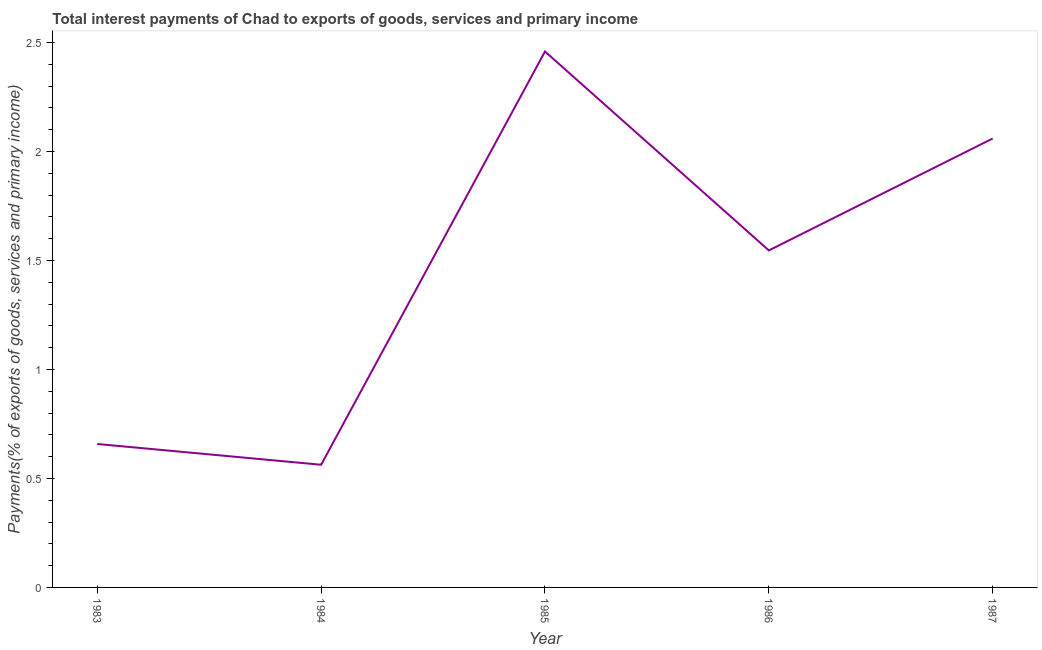What is the total interest payments on external debt in 1987?
Offer a terse response. 2.06. Across all years, what is the maximum total interest payments on external debt?
Provide a succinct answer. 2.46. Across all years, what is the minimum total interest payments on external debt?
Offer a very short reply. 0.56. In which year was the total interest payments on external debt maximum?
Provide a short and direct response. 1985. What is the sum of the total interest payments on external debt?
Ensure brevity in your answer.  7.28. What is the difference between the total interest payments on external debt in 1983 and 1984?
Provide a succinct answer. 0.1. What is the average total interest payments on external debt per year?
Give a very brief answer. 1.46. What is the median total interest payments on external debt?
Make the answer very short. 1.55. In how many years, is the total interest payments on external debt greater than 0.2 %?
Your answer should be compact. 5. What is the ratio of the total interest payments on external debt in 1983 to that in 1987?
Ensure brevity in your answer.  0.32. What is the difference between the highest and the second highest total interest payments on external debt?
Your answer should be very brief. 0.4. Is the sum of the total interest payments on external debt in 1983 and 1987 greater than the maximum total interest payments on external debt across all years?
Your answer should be compact. Yes. What is the difference between the highest and the lowest total interest payments on external debt?
Provide a succinct answer. 1.9. In how many years, is the total interest payments on external debt greater than the average total interest payments on external debt taken over all years?
Your answer should be compact. 3. Does the total interest payments on external debt monotonically increase over the years?
Your response must be concise. No. How many years are there in the graph?
Your answer should be compact. 5. Does the graph contain any zero values?
Ensure brevity in your answer.  No. Does the graph contain grids?
Keep it short and to the point. No. What is the title of the graph?
Make the answer very short. Total interest payments of Chad to exports of goods, services and primary income. What is the label or title of the X-axis?
Give a very brief answer. Year. What is the label or title of the Y-axis?
Ensure brevity in your answer.  Payments(% of exports of goods, services and primary income). What is the Payments(% of exports of goods, services and primary income) of 1983?
Make the answer very short. 0.66. What is the Payments(% of exports of goods, services and primary income) in 1984?
Your answer should be very brief. 0.56. What is the Payments(% of exports of goods, services and primary income) in 1985?
Your response must be concise. 2.46. What is the Payments(% of exports of goods, services and primary income) of 1986?
Provide a short and direct response. 1.55. What is the Payments(% of exports of goods, services and primary income) of 1987?
Your answer should be compact. 2.06. What is the difference between the Payments(% of exports of goods, services and primary income) in 1983 and 1984?
Give a very brief answer. 0.1. What is the difference between the Payments(% of exports of goods, services and primary income) in 1983 and 1985?
Make the answer very short. -1.8. What is the difference between the Payments(% of exports of goods, services and primary income) in 1983 and 1986?
Offer a terse response. -0.89. What is the difference between the Payments(% of exports of goods, services and primary income) in 1983 and 1987?
Make the answer very short. -1.4. What is the difference between the Payments(% of exports of goods, services and primary income) in 1984 and 1985?
Offer a very short reply. -1.9. What is the difference between the Payments(% of exports of goods, services and primary income) in 1984 and 1986?
Keep it short and to the point. -0.98. What is the difference between the Payments(% of exports of goods, services and primary income) in 1984 and 1987?
Offer a very short reply. -1.5. What is the difference between the Payments(% of exports of goods, services and primary income) in 1985 and 1986?
Your answer should be compact. 0.91. What is the difference between the Payments(% of exports of goods, services and primary income) in 1985 and 1987?
Give a very brief answer. 0.4. What is the difference between the Payments(% of exports of goods, services and primary income) in 1986 and 1987?
Ensure brevity in your answer.  -0.51. What is the ratio of the Payments(% of exports of goods, services and primary income) in 1983 to that in 1984?
Your answer should be very brief. 1.17. What is the ratio of the Payments(% of exports of goods, services and primary income) in 1983 to that in 1985?
Your answer should be compact. 0.27. What is the ratio of the Payments(% of exports of goods, services and primary income) in 1983 to that in 1986?
Provide a succinct answer. 0.43. What is the ratio of the Payments(% of exports of goods, services and primary income) in 1983 to that in 1987?
Give a very brief answer. 0.32. What is the ratio of the Payments(% of exports of goods, services and primary income) in 1984 to that in 1985?
Offer a terse response. 0.23. What is the ratio of the Payments(% of exports of goods, services and primary income) in 1984 to that in 1986?
Keep it short and to the point. 0.36. What is the ratio of the Payments(% of exports of goods, services and primary income) in 1984 to that in 1987?
Provide a succinct answer. 0.27. What is the ratio of the Payments(% of exports of goods, services and primary income) in 1985 to that in 1986?
Provide a succinct answer. 1.59. What is the ratio of the Payments(% of exports of goods, services and primary income) in 1985 to that in 1987?
Make the answer very short. 1.19. What is the ratio of the Payments(% of exports of goods, services and primary income) in 1986 to that in 1987?
Make the answer very short. 0.75. 